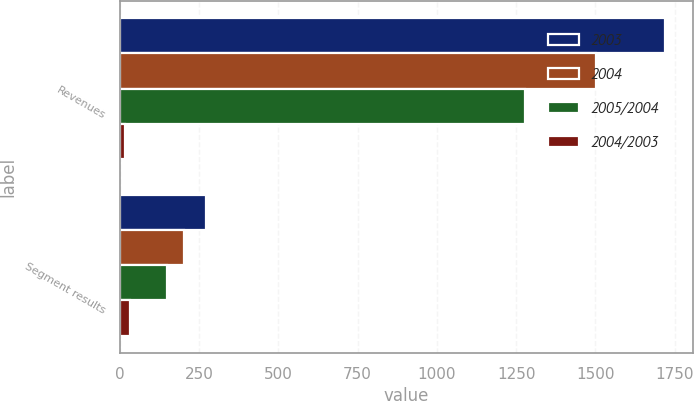<chart> <loc_0><loc_0><loc_500><loc_500><stacked_bar_chart><ecel><fcel>Revenues<fcel>Segment results<nl><fcel>2003<fcel>1721<fcel>271<nl><fcel>2004<fcel>1502<fcel>203<nl><fcel>2005/2004<fcel>1279<fcel>149<nl><fcel>2004/2003<fcel>15<fcel>33<nl></chart> 